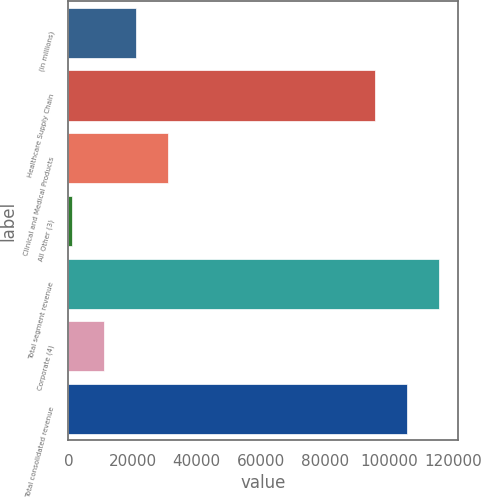Convert chart. <chart><loc_0><loc_0><loc_500><loc_500><bar_chart><fcel>(in millions)<fcel>Healthcare Supply Chain<fcel>Clinical and Medical Products<fcel>All Other (3)<fcel>Total segment revenue<fcel>Corporate (4)<fcel>Total consolidated revenue<nl><fcel>21079.6<fcel>95717.9<fcel>31110.2<fcel>1018.3<fcel>115779<fcel>11048.9<fcel>105749<nl></chart> 